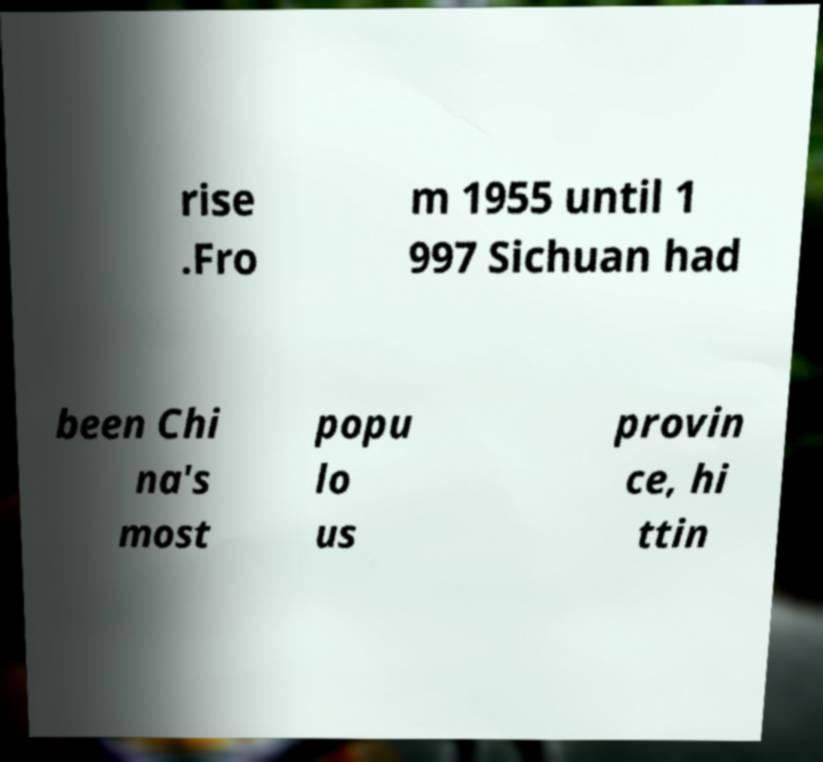Could you extract and type out the text from this image? rise .Fro m 1955 until 1 997 Sichuan had been Chi na's most popu lo us provin ce, hi ttin 